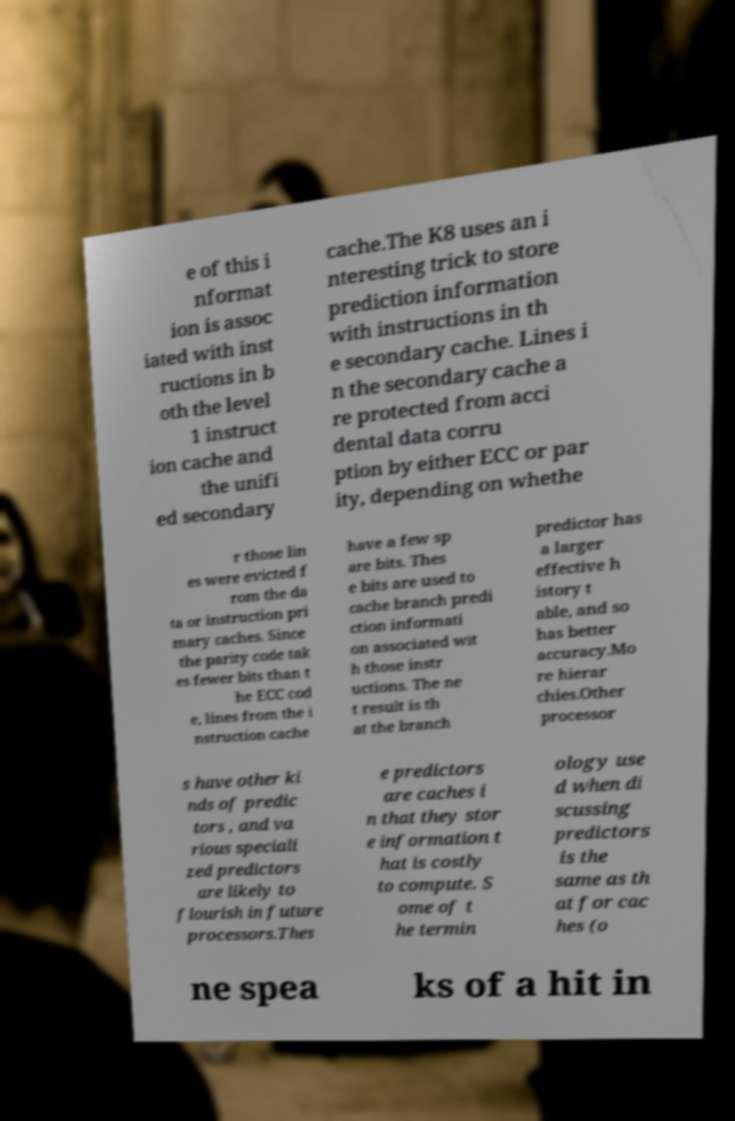Can you read and provide the text displayed in the image?This photo seems to have some interesting text. Can you extract and type it out for me? e of this i nformat ion is assoc iated with inst ructions in b oth the level 1 instruct ion cache and the unifi ed secondary cache.The K8 uses an i nteresting trick to store prediction information with instructions in th e secondary cache. Lines i n the secondary cache a re protected from acci dental data corru ption by either ECC or par ity, depending on whethe r those lin es were evicted f rom the da ta or instruction pri mary caches. Since the parity code tak es fewer bits than t he ECC cod e, lines from the i nstruction cache have a few sp are bits. Thes e bits are used to cache branch predi ction informati on associated wit h those instr uctions. The ne t result is th at the branch predictor has a larger effective h istory t able, and so has better accuracy.Mo re hierar chies.Other processor s have other ki nds of predic tors , and va rious speciali zed predictors are likely to flourish in future processors.Thes e predictors are caches i n that they stor e information t hat is costly to compute. S ome of t he termin ology use d when di scussing predictors is the same as th at for cac hes (o ne spea ks of a hit in 